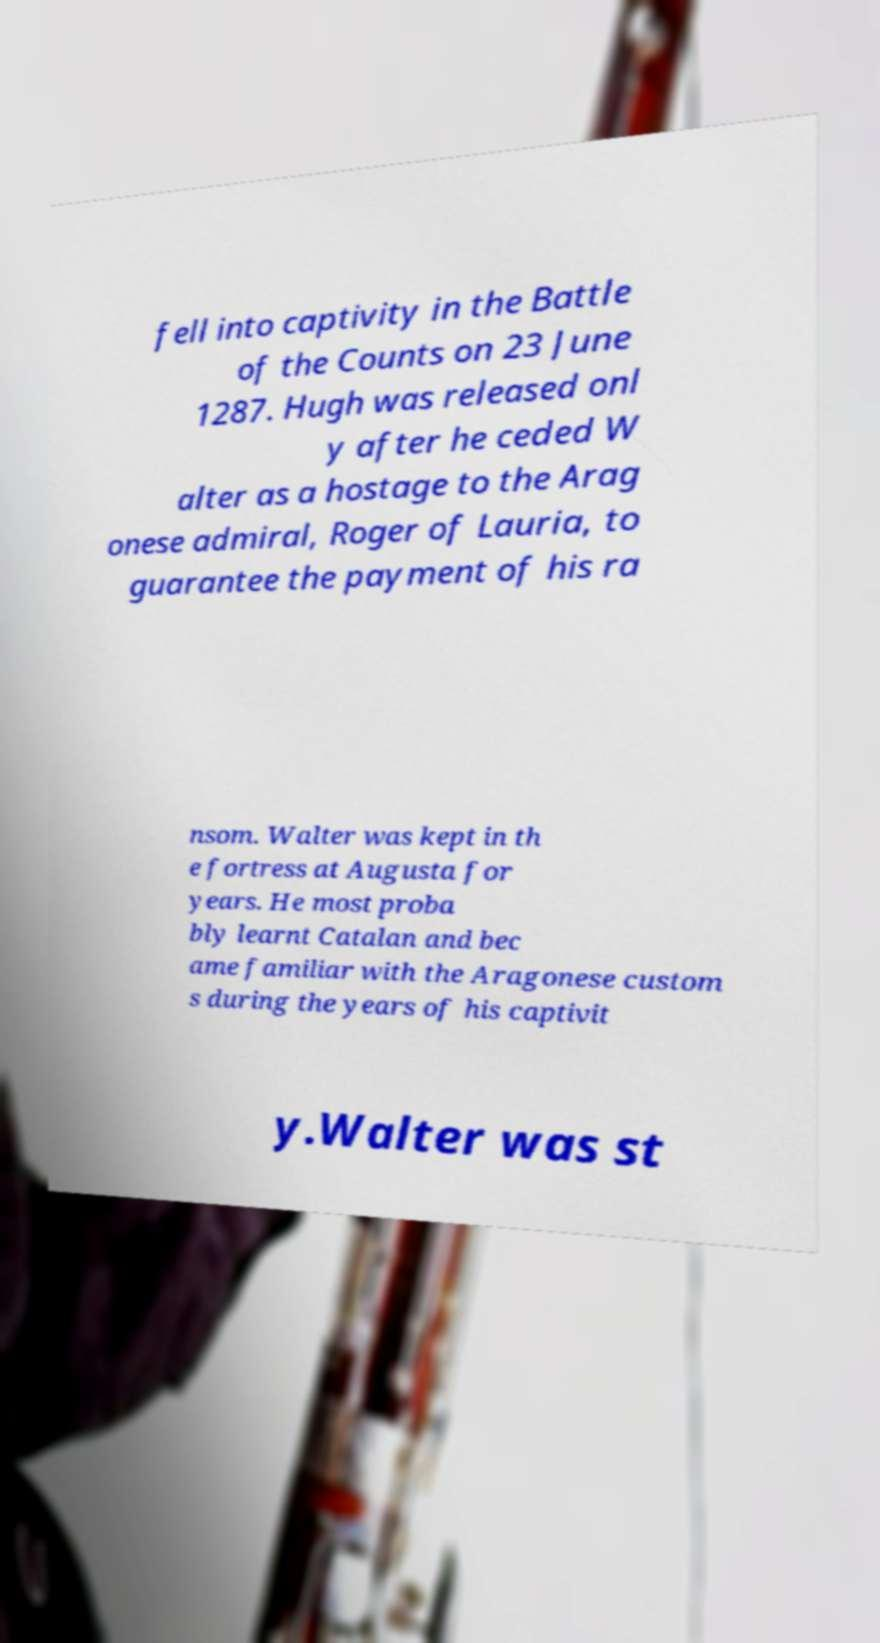There's text embedded in this image that I need extracted. Can you transcribe it verbatim? fell into captivity in the Battle of the Counts on 23 June 1287. Hugh was released onl y after he ceded W alter as a hostage to the Arag onese admiral, Roger of Lauria, to guarantee the payment of his ra nsom. Walter was kept in th e fortress at Augusta for years. He most proba bly learnt Catalan and bec ame familiar with the Aragonese custom s during the years of his captivit y.Walter was st 